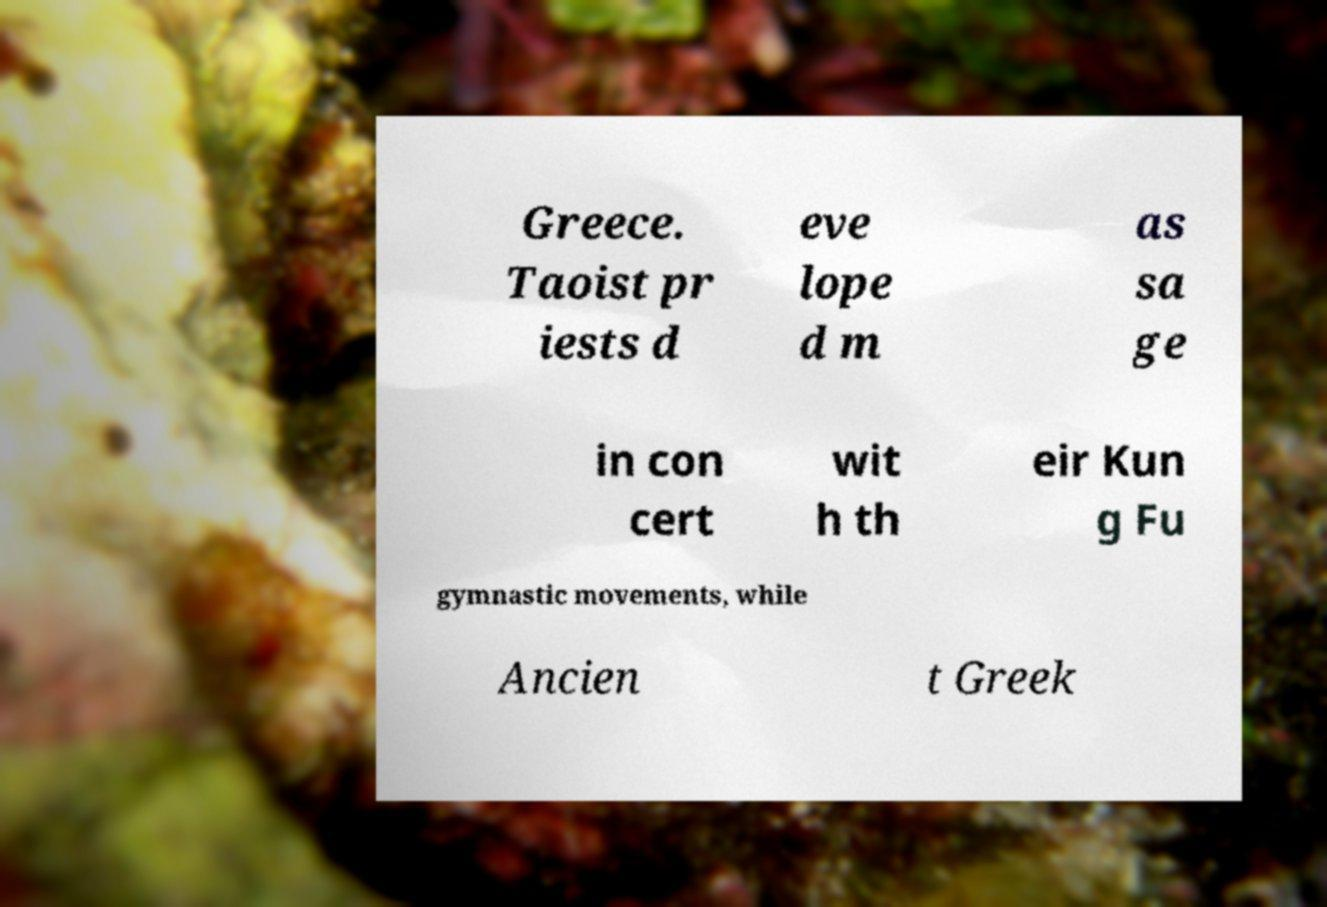Please read and relay the text visible in this image. What does it say? Greece. Taoist pr iests d eve lope d m as sa ge in con cert wit h th eir Kun g Fu gymnastic movements, while Ancien t Greek 